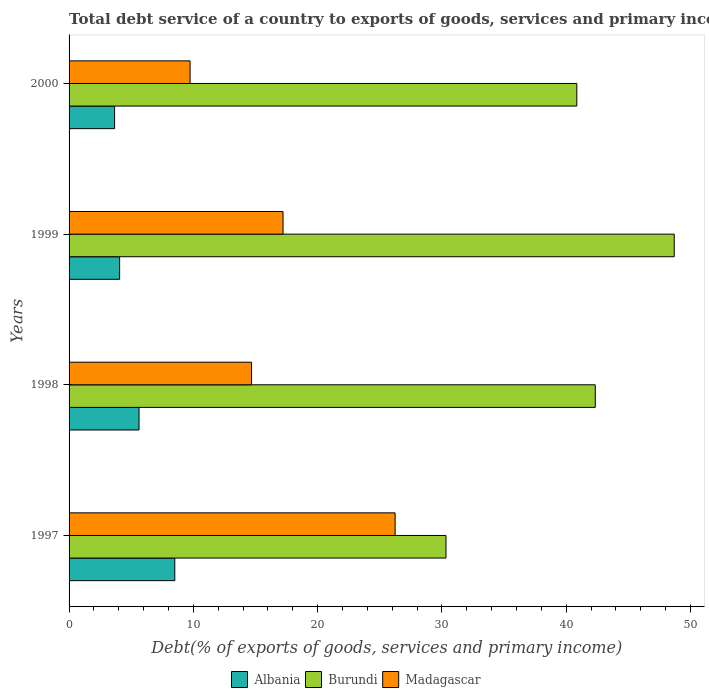How many groups of bars are there?
Your answer should be compact. 4. Are the number of bars per tick equal to the number of legend labels?
Offer a terse response. Yes. How many bars are there on the 1st tick from the top?
Your answer should be compact. 3. How many bars are there on the 4th tick from the bottom?
Offer a terse response. 3. What is the total debt service in Albania in 2000?
Keep it short and to the point. 3.66. Across all years, what is the maximum total debt service in Albania?
Offer a terse response. 8.51. Across all years, what is the minimum total debt service in Madagascar?
Offer a terse response. 9.74. In which year was the total debt service in Burundi minimum?
Your answer should be very brief. 1997. What is the total total debt service in Madagascar in the graph?
Offer a terse response. 67.87. What is the difference between the total debt service in Burundi in 1997 and that in 1998?
Provide a succinct answer. -12.01. What is the difference between the total debt service in Madagascar in 2000 and the total debt service in Burundi in 1997?
Offer a terse response. -20.59. What is the average total debt service in Madagascar per year?
Give a very brief answer. 16.97. In the year 1998, what is the difference between the total debt service in Burundi and total debt service in Albania?
Your response must be concise. 36.71. What is the ratio of the total debt service in Madagascar in 1998 to that in 1999?
Your answer should be very brief. 0.85. Is the difference between the total debt service in Burundi in 1998 and 2000 greater than the difference between the total debt service in Albania in 1998 and 2000?
Your answer should be compact. No. What is the difference between the highest and the second highest total debt service in Albania?
Offer a very short reply. 2.88. What is the difference between the highest and the lowest total debt service in Burundi?
Provide a short and direct response. 18.37. Is the sum of the total debt service in Albania in 1999 and 2000 greater than the maximum total debt service in Burundi across all years?
Give a very brief answer. No. What does the 1st bar from the top in 2000 represents?
Your answer should be compact. Madagascar. What does the 3rd bar from the bottom in 1999 represents?
Keep it short and to the point. Madagascar. Is it the case that in every year, the sum of the total debt service in Burundi and total debt service in Madagascar is greater than the total debt service in Albania?
Your answer should be very brief. Yes. How many bars are there?
Give a very brief answer. 12. Are all the bars in the graph horizontal?
Offer a very short reply. Yes. How many years are there in the graph?
Your answer should be compact. 4. What is the difference between two consecutive major ticks on the X-axis?
Keep it short and to the point. 10. Does the graph contain any zero values?
Provide a succinct answer. No. Does the graph contain grids?
Keep it short and to the point. No. Where does the legend appear in the graph?
Provide a succinct answer. Bottom center. How many legend labels are there?
Offer a very short reply. 3. How are the legend labels stacked?
Keep it short and to the point. Horizontal. What is the title of the graph?
Offer a terse response. Total debt service of a country to exports of goods, services and primary income. Does "Turkey" appear as one of the legend labels in the graph?
Provide a short and direct response. No. What is the label or title of the X-axis?
Provide a succinct answer. Debt(% of exports of goods, services and primary income). What is the label or title of the Y-axis?
Keep it short and to the point. Years. What is the Debt(% of exports of goods, services and primary income) in Albania in 1997?
Ensure brevity in your answer.  8.51. What is the Debt(% of exports of goods, services and primary income) in Burundi in 1997?
Your answer should be very brief. 30.33. What is the Debt(% of exports of goods, services and primary income) in Madagascar in 1997?
Provide a succinct answer. 26.24. What is the Debt(% of exports of goods, services and primary income) in Albania in 1998?
Keep it short and to the point. 5.63. What is the Debt(% of exports of goods, services and primary income) of Burundi in 1998?
Your answer should be very brief. 42.34. What is the Debt(% of exports of goods, services and primary income) in Madagascar in 1998?
Your answer should be very brief. 14.68. What is the Debt(% of exports of goods, services and primary income) of Albania in 1999?
Your answer should be compact. 4.07. What is the Debt(% of exports of goods, services and primary income) in Burundi in 1999?
Offer a very short reply. 48.69. What is the Debt(% of exports of goods, services and primary income) in Madagascar in 1999?
Your answer should be compact. 17.22. What is the Debt(% of exports of goods, services and primary income) in Albania in 2000?
Provide a succinct answer. 3.66. What is the Debt(% of exports of goods, services and primary income) of Burundi in 2000?
Provide a short and direct response. 40.86. What is the Debt(% of exports of goods, services and primary income) in Madagascar in 2000?
Your answer should be compact. 9.74. Across all years, what is the maximum Debt(% of exports of goods, services and primary income) of Albania?
Keep it short and to the point. 8.51. Across all years, what is the maximum Debt(% of exports of goods, services and primary income) in Burundi?
Offer a terse response. 48.69. Across all years, what is the maximum Debt(% of exports of goods, services and primary income) of Madagascar?
Keep it short and to the point. 26.24. Across all years, what is the minimum Debt(% of exports of goods, services and primary income) in Albania?
Your response must be concise. 3.66. Across all years, what is the minimum Debt(% of exports of goods, services and primary income) of Burundi?
Your answer should be very brief. 30.33. Across all years, what is the minimum Debt(% of exports of goods, services and primary income) in Madagascar?
Offer a very short reply. 9.74. What is the total Debt(% of exports of goods, services and primary income) of Albania in the graph?
Offer a very short reply. 21.87. What is the total Debt(% of exports of goods, services and primary income) in Burundi in the graph?
Your answer should be very brief. 162.22. What is the total Debt(% of exports of goods, services and primary income) in Madagascar in the graph?
Offer a terse response. 67.87. What is the difference between the Debt(% of exports of goods, services and primary income) of Albania in 1997 and that in 1998?
Provide a succinct answer. 2.88. What is the difference between the Debt(% of exports of goods, services and primary income) in Burundi in 1997 and that in 1998?
Offer a terse response. -12.01. What is the difference between the Debt(% of exports of goods, services and primary income) in Madagascar in 1997 and that in 1998?
Your response must be concise. 11.55. What is the difference between the Debt(% of exports of goods, services and primary income) of Albania in 1997 and that in 1999?
Offer a very short reply. 4.44. What is the difference between the Debt(% of exports of goods, services and primary income) of Burundi in 1997 and that in 1999?
Your answer should be compact. -18.37. What is the difference between the Debt(% of exports of goods, services and primary income) in Madagascar in 1997 and that in 1999?
Offer a very short reply. 9.02. What is the difference between the Debt(% of exports of goods, services and primary income) in Albania in 1997 and that in 2000?
Offer a terse response. 4.84. What is the difference between the Debt(% of exports of goods, services and primary income) of Burundi in 1997 and that in 2000?
Offer a terse response. -10.53. What is the difference between the Debt(% of exports of goods, services and primary income) of Madagascar in 1997 and that in 2000?
Make the answer very short. 16.5. What is the difference between the Debt(% of exports of goods, services and primary income) of Albania in 1998 and that in 1999?
Offer a terse response. 1.56. What is the difference between the Debt(% of exports of goods, services and primary income) in Burundi in 1998 and that in 1999?
Your answer should be compact. -6.35. What is the difference between the Debt(% of exports of goods, services and primary income) of Madagascar in 1998 and that in 1999?
Offer a very short reply. -2.53. What is the difference between the Debt(% of exports of goods, services and primary income) of Albania in 1998 and that in 2000?
Offer a terse response. 1.97. What is the difference between the Debt(% of exports of goods, services and primary income) of Burundi in 1998 and that in 2000?
Your answer should be very brief. 1.48. What is the difference between the Debt(% of exports of goods, services and primary income) in Madagascar in 1998 and that in 2000?
Your answer should be compact. 4.95. What is the difference between the Debt(% of exports of goods, services and primary income) in Albania in 1999 and that in 2000?
Offer a very short reply. 0.4. What is the difference between the Debt(% of exports of goods, services and primary income) in Burundi in 1999 and that in 2000?
Ensure brevity in your answer.  7.84. What is the difference between the Debt(% of exports of goods, services and primary income) of Madagascar in 1999 and that in 2000?
Provide a succinct answer. 7.48. What is the difference between the Debt(% of exports of goods, services and primary income) of Albania in 1997 and the Debt(% of exports of goods, services and primary income) of Burundi in 1998?
Provide a succinct answer. -33.83. What is the difference between the Debt(% of exports of goods, services and primary income) of Albania in 1997 and the Debt(% of exports of goods, services and primary income) of Madagascar in 1998?
Offer a very short reply. -6.18. What is the difference between the Debt(% of exports of goods, services and primary income) in Burundi in 1997 and the Debt(% of exports of goods, services and primary income) in Madagascar in 1998?
Your answer should be very brief. 15.64. What is the difference between the Debt(% of exports of goods, services and primary income) in Albania in 1997 and the Debt(% of exports of goods, services and primary income) in Burundi in 1999?
Your response must be concise. -40.19. What is the difference between the Debt(% of exports of goods, services and primary income) in Albania in 1997 and the Debt(% of exports of goods, services and primary income) in Madagascar in 1999?
Your answer should be very brief. -8.71. What is the difference between the Debt(% of exports of goods, services and primary income) in Burundi in 1997 and the Debt(% of exports of goods, services and primary income) in Madagascar in 1999?
Ensure brevity in your answer.  13.11. What is the difference between the Debt(% of exports of goods, services and primary income) of Albania in 1997 and the Debt(% of exports of goods, services and primary income) of Burundi in 2000?
Offer a very short reply. -32.35. What is the difference between the Debt(% of exports of goods, services and primary income) in Albania in 1997 and the Debt(% of exports of goods, services and primary income) in Madagascar in 2000?
Your answer should be very brief. -1.23. What is the difference between the Debt(% of exports of goods, services and primary income) in Burundi in 1997 and the Debt(% of exports of goods, services and primary income) in Madagascar in 2000?
Your answer should be compact. 20.59. What is the difference between the Debt(% of exports of goods, services and primary income) of Albania in 1998 and the Debt(% of exports of goods, services and primary income) of Burundi in 1999?
Provide a succinct answer. -43.06. What is the difference between the Debt(% of exports of goods, services and primary income) of Albania in 1998 and the Debt(% of exports of goods, services and primary income) of Madagascar in 1999?
Provide a short and direct response. -11.59. What is the difference between the Debt(% of exports of goods, services and primary income) in Burundi in 1998 and the Debt(% of exports of goods, services and primary income) in Madagascar in 1999?
Make the answer very short. 25.12. What is the difference between the Debt(% of exports of goods, services and primary income) in Albania in 1998 and the Debt(% of exports of goods, services and primary income) in Burundi in 2000?
Provide a succinct answer. -35.23. What is the difference between the Debt(% of exports of goods, services and primary income) of Albania in 1998 and the Debt(% of exports of goods, services and primary income) of Madagascar in 2000?
Make the answer very short. -4.11. What is the difference between the Debt(% of exports of goods, services and primary income) in Burundi in 1998 and the Debt(% of exports of goods, services and primary income) in Madagascar in 2000?
Offer a terse response. 32.6. What is the difference between the Debt(% of exports of goods, services and primary income) in Albania in 1999 and the Debt(% of exports of goods, services and primary income) in Burundi in 2000?
Provide a succinct answer. -36.79. What is the difference between the Debt(% of exports of goods, services and primary income) of Albania in 1999 and the Debt(% of exports of goods, services and primary income) of Madagascar in 2000?
Your answer should be very brief. -5.67. What is the difference between the Debt(% of exports of goods, services and primary income) of Burundi in 1999 and the Debt(% of exports of goods, services and primary income) of Madagascar in 2000?
Offer a very short reply. 38.96. What is the average Debt(% of exports of goods, services and primary income) in Albania per year?
Keep it short and to the point. 5.47. What is the average Debt(% of exports of goods, services and primary income) of Burundi per year?
Provide a succinct answer. 40.55. What is the average Debt(% of exports of goods, services and primary income) of Madagascar per year?
Provide a short and direct response. 16.97. In the year 1997, what is the difference between the Debt(% of exports of goods, services and primary income) of Albania and Debt(% of exports of goods, services and primary income) of Burundi?
Ensure brevity in your answer.  -21.82. In the year 1997, what is the difference between the Debt(% of exports of goods, services and primary income) in Albania and Debt(% of exports of goods, services and primary income) in Madagascar?
Offer a terse response. -17.73. In the year 1997, what is the difference between the Debt(% of exports of goods, services and primary income) of Burundi and Debt(% of exports of goods, services and primary income) of Madagascar?
Your answer should be very brief. 4.09. In the year 1998, what is the difference between the Debt(% of exports of goods, services and primary income) in Albania and Debt(% of exports of goods, services and primary income) in Burundi?
Give a very brief answer. -36.71. In the year 1998, what is the difference between the Debt(% of exports of goods, services and primary income) of Albania and Debt(% of exports of goods, services and primary income) of Madagascar?
Give a very brief answer. -9.06. In the year 1998, what is the difference between the Debt(% of exports of goods, services and primary income) of Burundi and Debt(% of exports of goods, services and primary income) of Madagascar?
Your answer should be very brief. 27.65. In the year 1999, what is the difference between the Debt(% of exports of goods, services and primary income) in Albania and Debt(% of exports of goods, services and primary income) in Burundi?
Keep it short and to the point. -44.63. In the year 1999, what is the difference between the Debt(% of exports of goods, services and primary income) in Albania and Debt(% of exports of goods, services and primary income) in Madagascar?
Provide a short and direct response. -13.15. In the year 1999, what is the difference between the Debt(% of exports of goods, services and primary income) of Burundi and Debt(% of exports of goods, services and primary income) of Madagascar?
Make the answer very short. 31.48. In the year 2000, what is the difference between the Debt(% of exports of goods, services and primary income) of Albania and Debt(% of exports of goods, services and primary income) of Burundi?
Your answer should be compact. -37.19. In the year 2000, what is the difference between the Debt(% of exports of goods, services and primary income) in Albania and Debt(% of exports of goods, services and primary income) in Madagascar?
Offer a very short reply. -6.07. In the year 2000, what is the difference between the Debt(% of exports of goods, services and primary income) of Burundi and Debt(% of exports of goods, services and primary income) of Madagascar?
Provide a succinct answer. 31.12. What is the ratio of the Debt(% of exports of goods, services and primary income) in Albania in 1997 to that in 1998?
Give a very brief answer. 1.51. What is the ratio of the Debt(% of exports of goods, services and primary income) of Burundi in 1997 to that in 1998?
Your response must be concise. 0.72. What is the ratio of the Debt(% of exports of goods, services and primary income) of Madagascar in 1997 to that in 1998?
Provide a succinct answer. 1.79. What is the ratio of the Debt(% of exports of goods, services and primary income) of Albania in 1997 to that in 1999?
Your answer should be very brief. 2.09. What is the ratio of the Debt(% of exports of goods, services and primary income) in Burundi in 1997 to that in 1999?
Give a very brief answer. 0.62. What is the ratio of the Debt(% of exports of goods, services and primary income) in Madagascar in 1997 to that in 1999?
Your answer should be compact. 1.52. What is the ratio of the Debt(% of exports of goods, services and primary income) of Albania in 1997 to that in 2000?
Provide a short and direct response. 2.32. What is the ratio of the Debt(% of exports of goods, services and primary income) of Burundi in 1997 to that in 2000?
Ensure brevity in your answer.  0.74. What is the ratio of the Debt(% of exports of goods, services and primary income) of Madagascar in 1997 to that in 2000?
Your answer should be compact. 2.69. What is the ratio of the Debt(% of exports of goods, services and primary income) in Albania in 1998 to that in 1999?
Offer a terse response. 1.38. What is the ratio of the Debt(% of exports of goods, services and primary income) of Burundi in 1998 to that in 1999?
Ensure brevity in your answer.  0.87. What is the ratio of the Debt(% of exports of goods, services and primary income) in Madagascar in 1998 to that in 1999?
Ensure brevity in your answer.  0.85. What is the ratio of the Debt(% of exports of goods, services and primary income) in Albania in 1998 to that in 2000?
Give a very brief answer. 1.54. What is the ratio of the Debt(% of exports of goods, services and primary income) in Burundi in 1998 to that in 2000?
Provide a short and direct response. 1.04. What is the ratio of the Debt(% of exports of goods, services and primary income) in Madagascar in 1998 to that in 2000?
Ensure brevity in your answer.  1.51. What is the ratio of the Debt(% of exports of goods, services and primary income) in Albania in 1999 to that in 2000?
Give a very brief answer. 1.11. What is the ratio of the Debt(% of exports of goods, services and primary income) of Burundi in 1999 to that in 2000?
Make the answer very short. 1.19. What is the ratio of the Debt(% of exports of goods, services and primary income) in Madagascar in 1999 to that in 2000?
Make the answer very short. 1.77. What is the difference between the highest and the second highest Debt(% of exports of goods, services and primary income) in Albania?
Offer a very short reply. 2.88. What is the difference between the highest and the second highest Debt(% of exports of goods, services and primary income) in Burundi?
Provide a short and direct response. 6.35. What is the difference between the highest and the second highest Debt(% of exports of goods, services and primary income) in Madagascar?
Offer a terse response. 9.02. What is the difference between the highest and the lowest Debt(% of exports of goods, services and primary income) in Albania?
Offer a very short reply. 4.84. What is the difference between the highest and the lowest Debt(% of exports of goods, services and primary income) of Burundi?
Your answer should be very brief. 18.37. What is the difference between the highest and the lowest Debt(% of exports of goods, services and primary income) of Madagascar?
Keep it short and to the point. 16.5. 